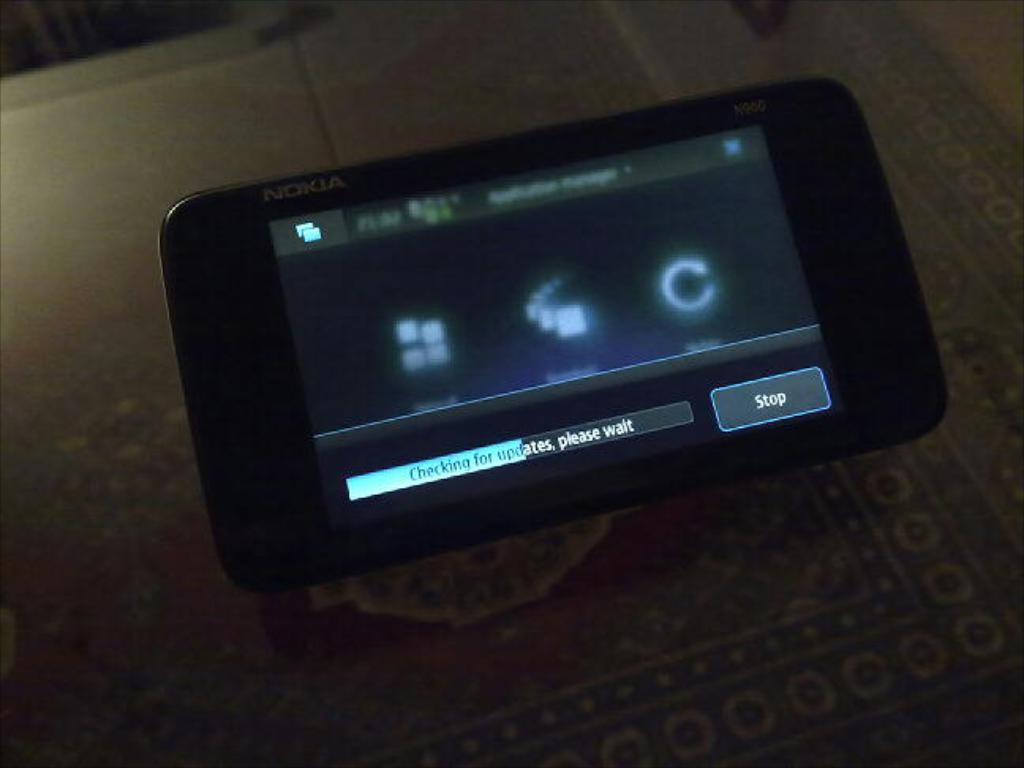Provide a one-sentence caption for the provided image. nokia phone with screen that has on it checking for updates, please wait. 